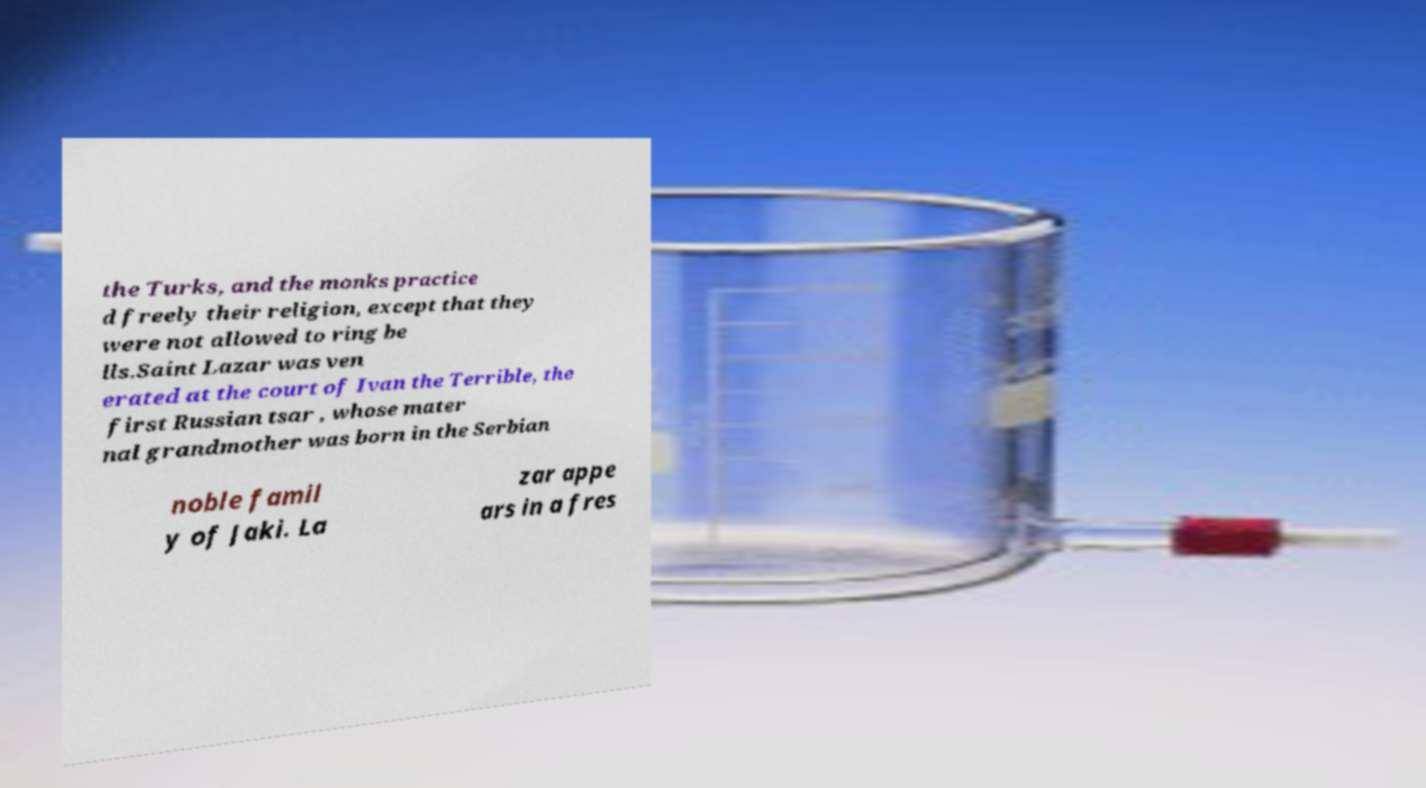Could you extract and type out the text from this image? the Turks, and the monks practice d freely their religion, except that they were not allowed to ring be lls.Saint Lazar was ven erated at the court of Ivan the Terrible, the first Russian tsar , whose mater nal grandmother was born in the Serbian noble famil y of Jaki. La zar appe ars in a fres 